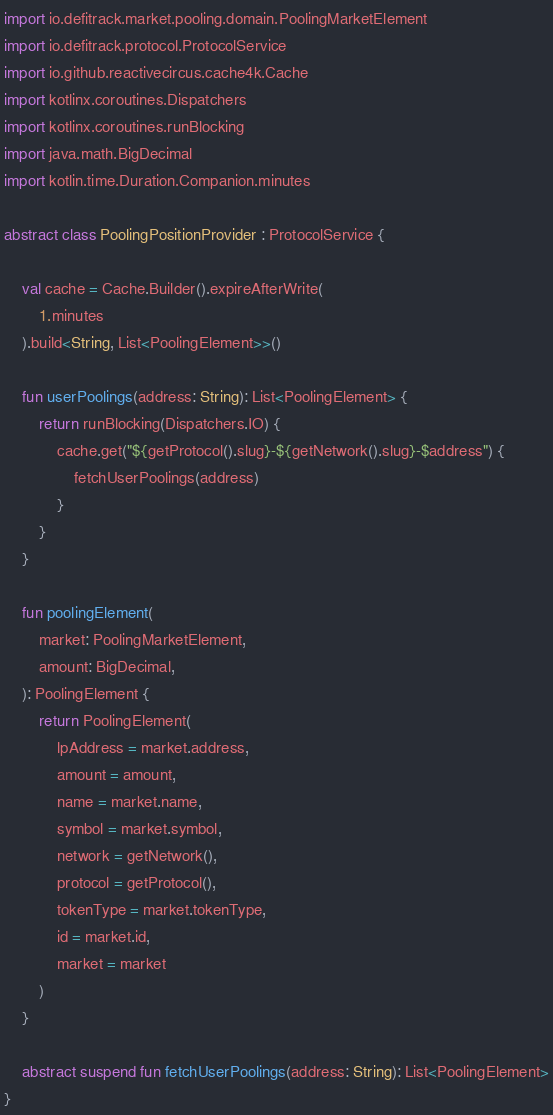<code> <loc_0><loc_0><loc_500><loc_500><_Kotlin_>import io.defitrack.market.pooling.domain.PoolingMarketElement
import io.defitrack.protocol.ProtocolService
import io.github.reactivecircus.cache4k.Cache
import kotlinx.coroutines.Dispatchers
import kotlinx.coroutines.runBlocking
import java.math.BigDecimal
import kotlin.time.Duration.Companion.minutes

abstract class PoolingPositionProvider : ProtocolService {

    val cache = Cache.Builder().expireAfterWrite(
        1.minutes
    ).build<String, List<PoolingElement>>()

    fun userPoolings(address: String): List<PoolingElement> {
        return runBlocking(Dispatchers.IO) {
            cache.get("${getProtocol().slug}-${getNetwork().slug}-$address") {
                fetchUserPoolings(address)
            }
        }
    }

    fun poolingElement(
        market: PoolingMarketElement,
        amount: BigDecimal,
    ): PoolingElement {
        return PoolingElement(
            lpAddress = market.address,
            amount = amount,
            name = market.name,
            symbol = market.symbol,
            network = getNetwork(),
            protocol = getProtocol(),
            tokenType = market.tokenType,
            id = market.id,
            market = market
        )
    }

    abstract suspend fun fetchUserPoolings(address: String): List<PoolingElement>
}</code> 